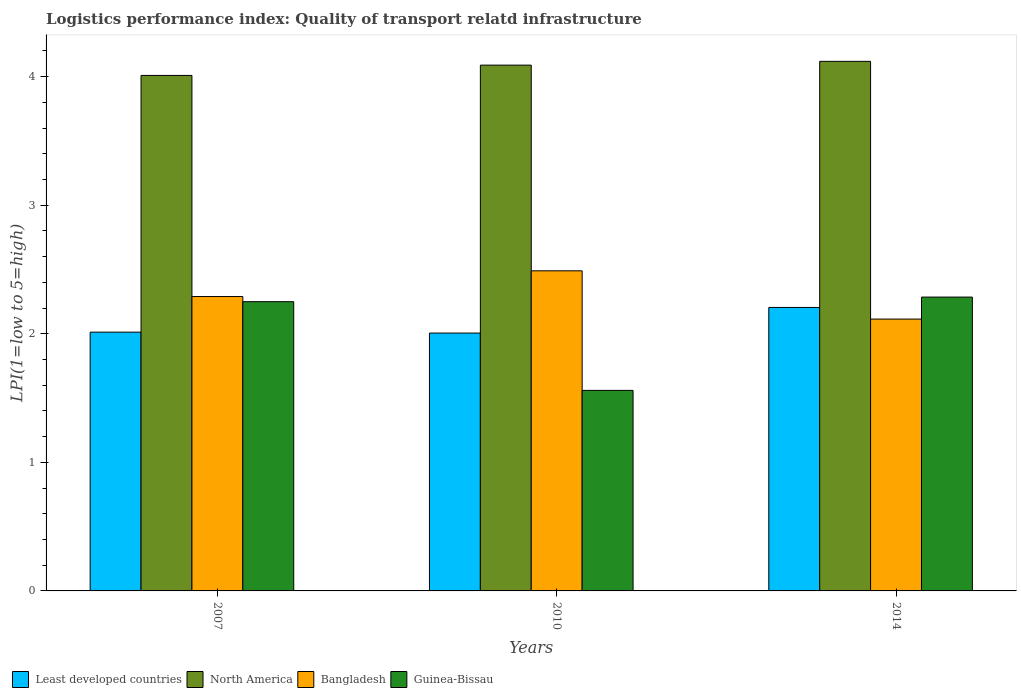How many groups of bars are there?
Give a very brief answer. 3. Are the number of bars on each tick of the X-axis equal?
Offer a terse response. Yes. How many bars are there on the 3rd tick from the left?
Offer a terse response. 4. How many bars are there on the 2nd tick from the right?
Keep it short and to the point. 4. In how many cases, is the number of bars for a given year not equal to the number of legend labels?
Your response must be concise. 0. What is the logistics performance index in Least developed countries in 2007?
Provide a short and direct response. 2.01. Across all years, what is the maximum logistics performance index in Guinea-Bissau?
Ensure brevity in your answer.  2.29. Across all years, what is the minimum logistics performance index in North America?
Give a very brief answer. 4.01. In which year was the logistics performance index in Least developed countries minimum?
Your answer should be very brief. 2010. What is the total logistics performance index in Bangladesh in the graph?
Your response must be concise. 6.89. What is the difference between the logistics performance index in Bangladesh in 2007 and that in 2010?
Keep it short and to the point. -0.2. What is the difference between the logistics performance index in North America in 2007 and the logistics performance index in Bangladesh in 2010?
Offer a terse response. 1.52. What is the average logistics performance index in Bangladesh per year?
Your response must be concise. 2.3. In the year 2010, what is the difference between the logistics performance index in Guinea-Bissau and logistics performance index in Bangladesh?
Provide a short and direct response. -0.93. In how many years, is the logistics performance index in North America greater than 2.4?
Your answer should be very brief. 3. What is the ratio of the logistics performance index in Guinea-Bissau in 2007 to that in 2010?
Keep it short and to the point. 1.44. Is the logistics performance index in Bangladesh in 2010 less than that in 2014?
Your answer should be very brief. No. What is the difference between the highest and the second highest logistics performance index in North America?
Keep it short and to the point. 0.03. What is the difference between the highest and the lowest logistics performance index in Least developed countries?
Provide a short and direct response. 0.2. What does the 4th bar from the right in 2014 represents?
Your response must be concise. Least developed countries. How many years are there in the graph?
Offer a terse response. 3. Does the graph contain grids?
Your response must be concise. No. Where does the legend appear in the graph?
Your response must be concise. Bottom left. How many legend labels are there?
Offer a terse response. 4. How are the legend labels stacked?
Your response must be concise. Horizontal. What is the title of the graph?
Make the answer very short. Logistics performance index: Quality of transport relatd infrastructure. What is the label or title of the X-axis?
Your answer should be very brief. Years. What is the label or title of the Y-axis?
Provide a short and direct response. LPI(1=low to 5=high). What is the LPI(1=low to 5=high) in Least developed countries in 2007?
Offer a terse response. 2.01. What is the LPI(1=low to 5=high) of North America in 2007?
Your answer should be very brief. 4.01. What is the LPI(1=low to 5=high) of Bangladesh in 2007?
Your answer should be compact. 2.29. What is the LPI(1=low to 5=high) of Guinea-Bissau in 2007?
Make the answer very short. 2.25. What is the LPI(1=low to 5=high) in Least developed countries in 2010?
Give a very brief answer. 2.01. What is the LPI(1=low to 5=high) of North America in 2010?
Offer a very short reply. 4.09. What is the LPI(1=low to 5=high) in Bangladesh in 2010?
Give a very brief answer. 2.49. What is the LPI(1=low to 5=high) in Guinea-Bissau in 2010?
Provide a succinct answer. 1.56. What is the LPI(1=low to 5=high) of Least developed countries in 2014?
Your answer should be compact. 2.21. What is the LPI(1=low to 5=high) in North America in 2014?
Your answer should be compact. 4.12. What is the LPI(1=low to 5=high) of Bangladesh in 2014?
Offer a terse response. 2.11. What is the LPI(1=low to 5=high) of Guinea-Bissau in 2014?
Ensure brevity in your answer.  2.29. Across all years, what is the maximum LPI(1=low to 5=high) in Least developed countries?
Provide a succinct answer. 2.21. Across all years, what is the maximum LPI(1=low to 5=high) in North America?
Provide a succinct answer. 4.12. Across all years, what is the maximum LPI(1=low to 5=high) of Bangladesh?
Give a very brief answer. 2.49. Across all years, what is the maximum LPI(1=low to 5=high) of Guinea-Bissau?
Make the answer very short. 2.29. Across all years, what is the minimum LPI(1=low to 5=high) of Least developed countries?
Your answer should be compact. 2.01. Across all years, what is the minimum LPI(1=low to 5=high) of North America?
Your answer should be very brief. 4.01. Across all years, what is the minimum LPI(1=low to 5=high) in Bangladesh?
Offer a terse response. 2.11. Across all years, what is the minimum LPI(1=low to 5=high) of Guinea-Bissau?
Provide a short and direct response. 1.56. What is the total LPI(1=low to 5=high) in Least developed countries in the graph?
Keep it short and to the point. 6.22. What is the total LPI(1=low to 5=high) of North America in the graph?
Keep it short and to the point. 12.22. What is the total LPI(1=low to 5=high) in Bangladesh in the graph?
Provide a succinct answer. 6.89. What is the total LPI(1=low to 5=high) of Guinea-Bissau in the graph?
Your answer should be very brief. 6.1. What is the difference between the LPI(1=low to 5=high) of Least developed countries in 2007 and that in 2010?
Give a very brief answer. 0.01. What is the difference between the LPI(1=low to 5=high) in North America in 2007 and that in 2010?
Provide a short and direct response. -0.08. What is the difference between the LPI(1=low to 5=high) in Guinea-Bissau in 2007 and that in 2010?
Your answer should be very brief. 0.69. What is the difference between the LPI(1=low to 5=high) in Least developed countries in 2007 and that in 2014?
Offer a terse response. -0.19. What is the difference between the LPI(1=low to 5=high) of North America in 2007 and that in 2014?
Your answer should be compact. -0.11. What is the difference between the LPI(1=low to 5=high) in Bangladesh in 2007 and that in 2014?
Your answer should be compact. 0.18. What is the difference between the LPI(1=low to 5=high) in Guinea-Bissau in 2007 and that in 2014?
Keep it short and to the point. -0.04. What is the difference between the LPI(1=low to 5=high) of Least developed countries in 2010 and that in 2014?
Provide a short and direct response. -0.2. What is the difference between the LPI(1=low to 5=high) in North America in 2010 and that in 2014?
Give a very brief answer. -0.03. What is the difference between the LPI(1=low to 5=high) in Bangladesh in 2010 and that in 2014?
Your answer should be very brief. 0.38. What is the difference between the LPI(1=low to 5=high) of Guinea-Bissau in 2010 and that in 2014?
Provide a succinct answer. -0.73. What is the difference between the LPI(1=low to 5=high) of Least developed countries in 2007 and the LPI(1=low to 5=high) of North America in 2010?
Provide a succinct answer. -2.08. What is the difference between the LPI(1=low to 5=high) in Least developed countries in 2007 and the LPI(1=low to 5=high) in Bangladesh in 2010?
Your answer should be compact. -0.48. What is the difference between the LPI(1=low to 5=high) in Least developed countries in 2007 and the LPI(1=low to 5=high) in Guinea-Bissau in 2010?
Offer a very short reply. 0.45. What is the difference between the LPI(1=low to 5=high) in North America in 2007 and the LPI(1=low to 5=high) in Bangladesh in 2010?
Keep it short and to the point. 1.52. What is the difference between the LPI(1=low to 5=high) in North America in 2007 and the LPI(1=low to 5=high) in Guinea-Bissau in 2010?
Your answer should be compact. 2.45. What is the difference between the LPI(1=low to 5=high) in Bangladesh in 2007 and the LPI(1=low to 5=high) in Guinea-Bissau in 2010?
Your answer should be very brief. 0.73. What is the difference between the LPI(1=low to 5=high) in Least developed countries in 2007 and the LPI(1=low to 5=high) in North America in 2014?
Provide a short and direct response. -2.11. What is the difference between the LPI(1=low to 5=high) in Least developed countries in 2007 and the LPI(1=low to 5=high) in Bangladesh in 2014?
Your response must be concise. -0.1. What is the difference between the LPI(1=low to 5=high) of Least developed countries in 2007 and the LPI(1=low to 5=high) of Guinea-Bissau in 2014?
Make the answer very short. -0.27. What is the difference between the LPI(1=low to 5=high) of North America in 2007 and the LPI(1=low to 5=high) of Bangladesh in 2014?
Offer a terse response. 1.9. What is the difference between the LPI(1=low to 5=high) of North America in 2007 and the LPI(1=low to 5=high) of Guinea-Bissau in 2014?
Provide a short and direct response. 1.72. What is the difference between the LPI(1=low to 5=high) of Bangladesh in 2007 and the LPI(1=low to 5=high) of Guinea-Bissau in 2014?
Ensure brevity in your answer.  0. What is the difference between the LPI(1=low to 5=high) of Least developed countries in 2010 and the LPI(1=low to 5=high) of North America in 2014?
Provide a short and direct response. -2.11. What is the difference between the LPI(1=low to 5=high) in Least developed countries in 2010 and the LPI(1=low to 5=high) in Bangladesh in 2014?
Offer a terse response. -0.11. What is the difference between the LPI(1=low to 5=high) in Least developed countries in 2010 and the LPI(1=low to 5=high) in Guinea-Bissau in 2014?
Provide a short and direct response. -0.28. What is the difference between the LPI(1=low to 5=high) of North America in 2010 and the LPI(1=low to 5=high) of Bangladesh in 2014?
Your response must be concise. 1.98. What is the difference between the LPI(1=low to 5=high) in North America in 2010 and the LPI(1=low to 5=high) in Guinea-Bissau in 2014?
Your answer should be compact. 1.8. What is the difference between the LPI(1=low to 5=high) of Bangladesh in 2010 and the LPI(1=low to 5=high) of Guinea-Bissau in 2014?
Your response must be concise. 0.2. What is the average LPI(1=low to 5=high) in Least developed countries per year?
Ensure brevity in your answer.  2.07. What is the average LPI(1=low to 5=high) of North America per year?
Offer a very short reply. 4.07. What is the average LPI(1=low to 5=high) of Bangladesh per year?
Provide a short and direct response. 2.3. What is the average LPI(1=low to 5=high) in Guinea-Bissau per year?
Your answer should be very brief. 2.03. In the year 2007, what is the difference between the LPI(1=low to 5=high) of Least developed countries and LPI(1=low to 5=high) of North America?
Your response must be concise. -2. In the year 2007, what is the difference between the LPI(1=low to 5=high) of Least developed countries and LPI(1=low to 5=high) of Bangladesh?
Provide a succinct answer. -0.28. In the year 2007, what is the difference between the LPI(1=low to 5=high) of Least developed countries and LPI(1=low to 5=high) of Guinea-Bissau?
Provide a short and direct response. -0.24. In the year 2007, what is the difference between the LPI(1=low to 5=high) of North America and LPI(1=low to 5=high) of Bangladesh?
Ensure brevity in your answer.  1.72. In the year 2007, what is the difference between the LPI(1=low to 5=high) in North America and LPI(1=low to 5=high) in Guinea-Bissau?
Your answer should be compact. 1.76. In the year 2010, what is the difference between the LPI(1=low to 5=high) of Least developed countries and LPI(1=low to 5=high) of North America?
Make the answer very short. -2.08. In the year 2010, what is the difference between the LPI(1=low to 5=high) in Least developed countries and LPI(1=low to 5=high) in Bangladesh?
Your response must be concise. -0.48. In the year 2010, what is the difference between the LPI(1=low to 5=high) in Least developed countries and LPI(1=low to 5=high) in Guinea-Bissau?
Give a very brief answer. 0.45. In the year 2010, what is the difference between the LPI(1=low to 5=high) in North America and LPI(1=low to 5=high) in Bangladesh?
Provide a succinct answer. 1.6. In the year 2010, what is the difference between the LPI(1=low to 5=high) of North America and LPI(1=low to 5=high) of Guinea-Bissau?
Your answer should be very brief. 2.53. In the year 2010, what is the difference between the LPI(1=low to 5=high) in Bangladesh and LPI(1=low to 5=high) in Guinea-Bissau?
Offer a terse response. 0.93. In the year 2014, what is the difference between the LPI(1=low to 5=high) in Least developed countries and LPI(1=low to 5=high) in North America?
Ensure brevity in your answer.  -1.91. In the year 2014, what is the difference between the LPI(1=low to 5=high) of Least developed countries and LPI(1=low to 5=high) of Bangladesh?
Offer a very short reply. 0.09. In the year 2014, what is the difference between the LPI(1=low to 5=high) of Least developed countries and LPI(1=low to 5=high) of Guinea-Bissau?
Your response must be concise. -0.08. In the year 2014, what is the difference between the LPI(1=low to 5=high) of North America and LPI(1=low to 5=high) of Bangladesh?
Keep it short and to the point. 2. In the year 2014, what is the difference between the LPI(1=low to 5=high) in North America and LPI(1=low to 5=high) in Guinea-Bissau?
Make the answer very short. 1.83. In the year 2014, what is the difference between the LPI(1=low to 5=high) in Bangladesh and LPI(1=low to 5=high) in Guinea-Bissau?
Offer a very short reply. -0.17. What is the ratio of the LPI(1=low to 5=high) of Least developed countries in 2007 to that in 2010?
Make the answer very short. 1. What is the ratio of the LPI(1=low to 5=high) of North America in 2007 to that in 2010?
Your answer should be very brief. 0.98. What is the ratio of the LPI(1=low to 5=high) of Bangladesh in 2007 to that in 2010?
Offer a terse response. 0.92. What is the ratio of the LPI(1=low to 5=high) of Guinea-Bissau in 2007 to that in 2010?
Give a very brief answer. 1.44. What is the ratio of the LPI(1=low to 5=high) of Least developed countries in 2007 to that in 2014?
Offer a very short reply. 0.91. What is the ratio of the LPI(1=low to 5=high) of North America in 2007 to that in 2014?
Your response must be concise. 0.97. What is the ratio of the LPI(1=low to 5=high) of Bangladesh in 2007 to that in 2014?
Your response must be concise. 1.08. What is the ratio of the LPI(1=low to 5=high) in Guinea-Bissau in 2007 to that in 2014?
Your response must be concise. 0.98. What is the ratio of the LPI(1=low to 5=high) in Least developed countries in 2010 to that in 2014?
Offer a very short reply. 0.91. What is the ratio of the LPI(1=low to 5=high) of North America in 2010 to that in 2014?
Provide a short and direct response. 0.99. What is the ratio of the LPI(1=low to 5=high) in Bangladesh in 2010 to that in 2014?
Ensure brevity in your answer.  1.18. What is the ratio of the LPI(1=low to 5=high) in Guinea-Bissau in 2010 to that in 2014?
Provide a short and direct response. 0.68. What is the difference between the highest and the second highest LPI(1=low to 5=high) of Least developed countries?
Provide a succinct answer. 0.19. What is the difference between the highest and the second highest LPI(1=low to 5=high) in North America?
Make the answer very short. 0.03. What is the difference between the highest and the second highest LPI(1=low to 5=high) of Guinea-Bissau?
Ensure brevity in your answer.  0.04. What is the difference between the highest and the lowest LPI(1=low to 5=high) in Least developed countries?
Your response must be concise. 0.2. What is the difference between the highest and the lowest LPI(1=low to 5=high) of North America?
Make the answer very short. 0.11. What is the difference between the highest and the lowest LPI(1=low to 5=high) of Bangladesh?
Your response must be concise. 0.38. What is the difference between the highest and the lowest LPI(1=low to 5=high) in Guinea-Bissau?
Offer a very short reply. 0.73. 